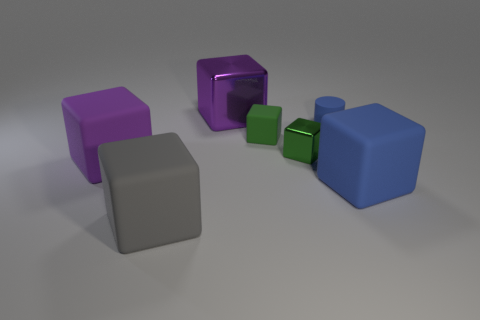Subtract 2 blocks. How many blocks are left? 4 Subtract all blue matte cubes. How many cubes are left? 5 Subtract all blue blocks. How many blocks are left? 5 Subtract all yellow blocks. Subtract all red cylinders. How many blocks are left? 6 Add 1 large shiny cubes. How many objects exist? 8 Subtract all cylinders. How many objects are left? 6 Add 7 large purple shiny cubes. How many large purple shiny cubes are left? 8 Add 7 tiny yellow metal things. How many tiny yellow metal things exist? 7 Subtract 0 cyan cubes. How many objects are left? 7 Subtract all blue rubber cylinders. Subtract all blue matte cylinders. How many objects are left? 5 